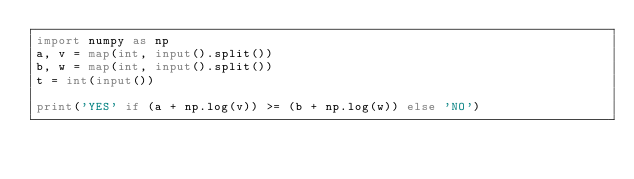Convert code to text. <code><loc_0><loc_0><loc_500><loc_500><_Python_>import numpy as np
a, v = map(int, input().split())
b, w = map(int, input().split())
t = int(input())

print('YES' if (a + np.log(v)) >= (b + np.log(w)) else 'NO')</code> 